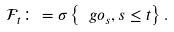<formula> <loc_0><loc_0><loc_500><loc_500>\mathcal { F } _ { t } \colon = \sigma \left \{ \ g o _ { s } , s \leq t \right \} .</formula> 